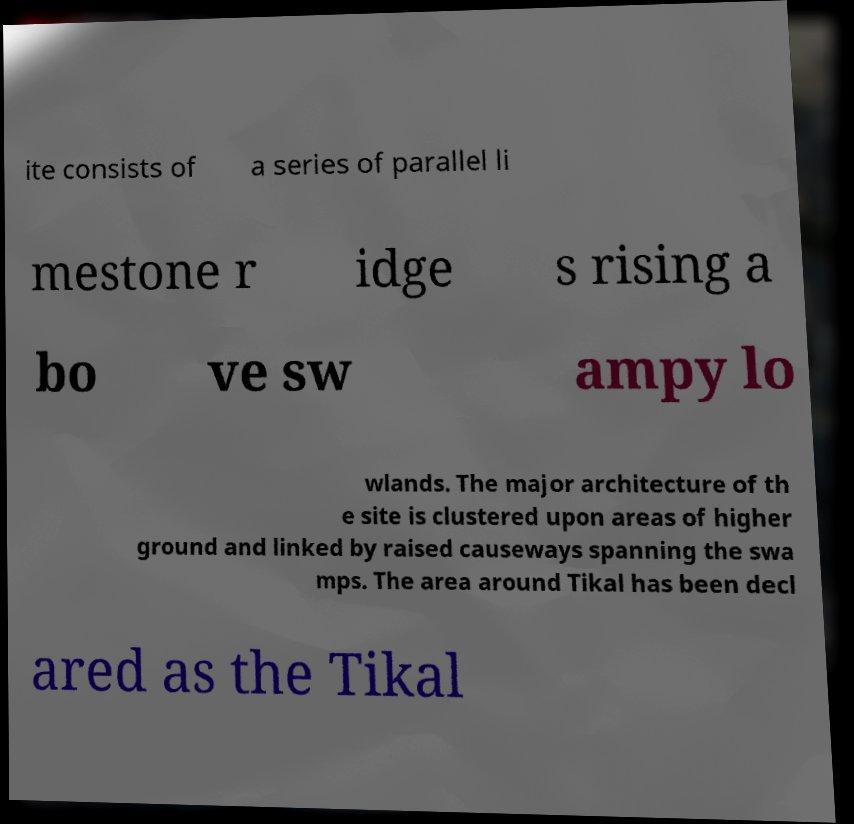Please identify and transcribe the text found in this image. ite consists of a series of parallel li mestone r idge s rising a bo ve sw ampy lo wlands. The major architecture of th e site is clustered upon areas of higher ground and linked by raised causeways spanning the swa mps. The area around Tikal has been decl ared as the Tikal 